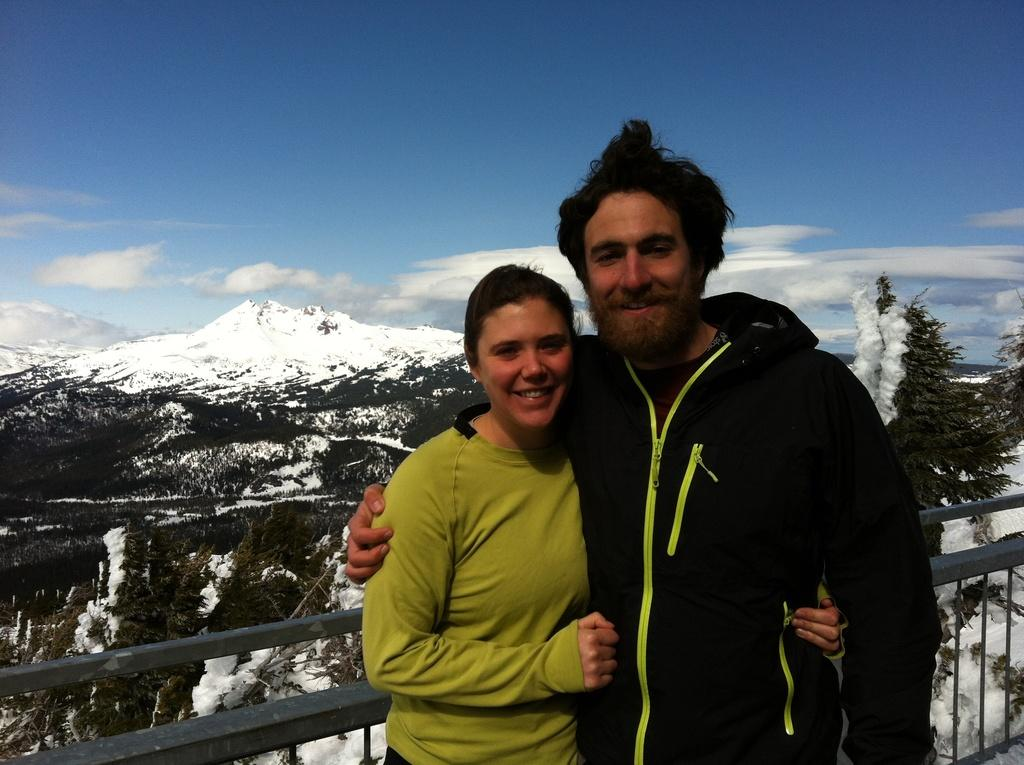Who is present in the image? There is a couple in the image. What are the couple doing in the image? The couple is standing and holding each other. What is located behind the couple in the image? There is a fence wall behind the couple. What can be seen in the background of the image? There are trees and mountains covered with snow in the background of the image. What type of apples can be smelled in the image? There are no apples or any scent mentioned in the image; it only features a couple, a fence wall, trees, and snow-covered mountains. 